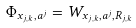Convert formula to latex. <formula><loc_0><loc_0><loc_500><loc_500>\Phi _ { x _ { j , k } , a ^ { j } } = W _ { x _ { j , k } , a ^ { j } , R _ { j , k } }</formula> 